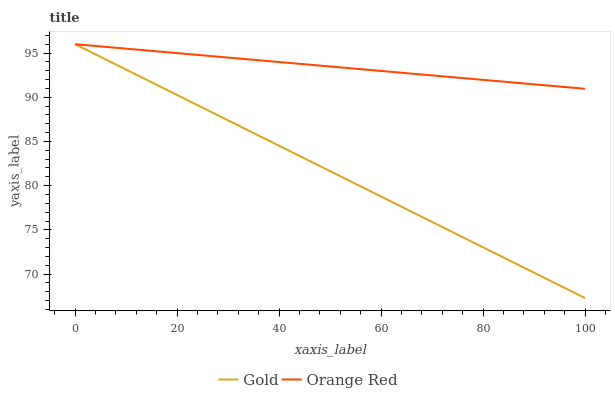Does Gold have the minimum area under the curve?
Answer yes or no. Yes. Does Orange Red have the maximum area under the curve?
Answer yes or no. Yes. Does Gold have the maximum area under the curve?
Answer yes or no. No. Is Orange Red the smoothest?
Answer yes or no. Yes. Is Gold the roughest?
Answer yes or no. Yes. Is Gold the smoothest?
Answer yes or no. No. Does Gold have the lowest value?
Answer yes or no. Yes. Does Gold have the highest value?
Answer yes or no. Yes. Does Gold intersect Orange Red?
Answer yes or no. Yes. Is Gold less than Orange Red?
Answer yes or no. No. Is Gold greater than Orange Red?
Answer yes or no. No. 